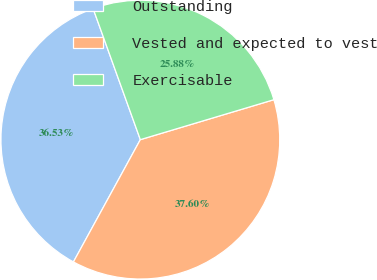Convert chart to OTSL. <chart><loc_0><loc_0><loc_500><loc_500><pie_chart><fcel>Outstanding<fcel>Vested and expected to vest<fcel>Exercisable<nl><fcel>36.53%<fcel>37.6%<fcel>25.88%<nl></chart> 